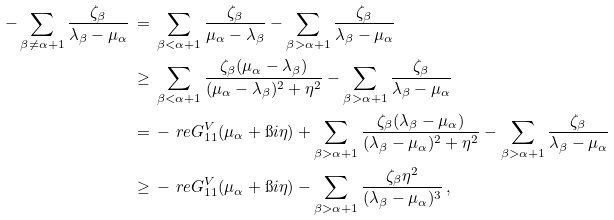Convert formula to latex. <formula><loc_0><loc_0><loc_500><loc_500>- \sum _ { \beta \neq \alpha + 1 } \frac { \zeta _ { \beta } } { \lambda _ { \beta } - \mu _ { \alpha } } & \, = \, \sum _ { \beta < \alpha + 1 } \frac { \zeta _ { \beta } } { \mu _ { \alpha } - \lambda _ { \beta } } - \sum _ { \beta > \alpha + 1 } \frac { \zeta _ { \beta } } { \lambda _ { \beta } - \mu _ { \alpha } } \\ & \, \geq \, \sum _ { \beta < \alpha + 1 } \frac { \zeta _ { \beta } ( \mu _ { \alpha } - \lambda _ { \beta } ) } { ( \mu _ { \alpha } - \lambda _ { \beta } ) ^ { 2 } + \eta ^ { 2 } } - \sum _ { \beta > \alpha + 1 } \frac { \zeta _ { \beta } } { \lambda _ { \beta } - \mu _ { \alpha } } \\ & \, = \, - \ r e G ^ { V } _ { 1 1 } ( \mu _ { \alpha } + \i i \eta ) + \sum _ { \beta > \alpha + 1 } \frac { \zeta _ { \beta } ( \lambda _ { \beta } - \mu _ { \alpha } ) } { ( \lambda _ { \beta } - \mu _ { \alpha } ) ^ { 2 } + \eta ^ { 2 } } - \sum _ { \beta > \alpha + 1 } \frac { \zeta _ { \beta } } { \lambda _ { \beta } - \mu _ { \alpha } } \\ & \, \geq \, - \ r e G ^ { V } _ { 1 1 } ( \mu _ { \alpha } + \i i \eta ) - \sum _ { \beta > \alpha + 1 } \frac { \zeta _ { \beta } \eta ^ { 2 } } { ( \lambda _ { \beta } - \mu _ { \alpha } ) ^ { 3 } } \, ,</formula> 